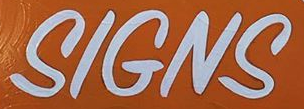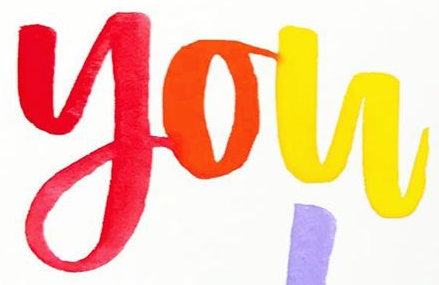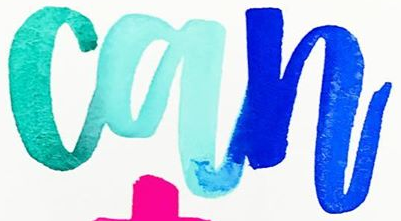What text is displayed in these images sequentially, separated by a semicolon? SIGNS; you; can 